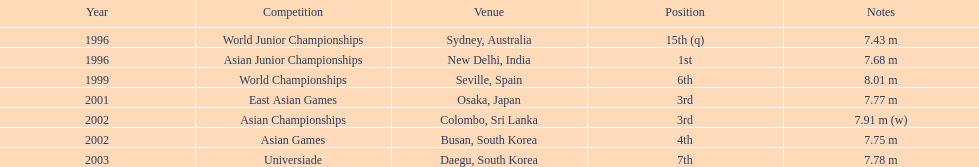In which event did this person take part in right before the east asian games in 2001? World Championships. 